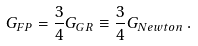Convert formula to latex. <formula><loc_0><loc_0><loc_500><loc_500>G _ { F P } = \frac { 3 } { 4 } G _ { G R } \equiv \frac { 3 } { 4 } G _ { N e w t o n } \, .</formula> 